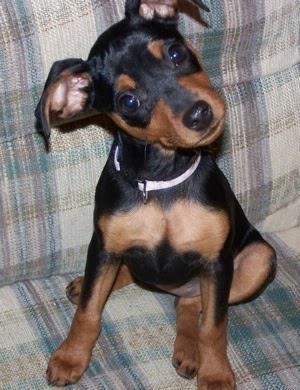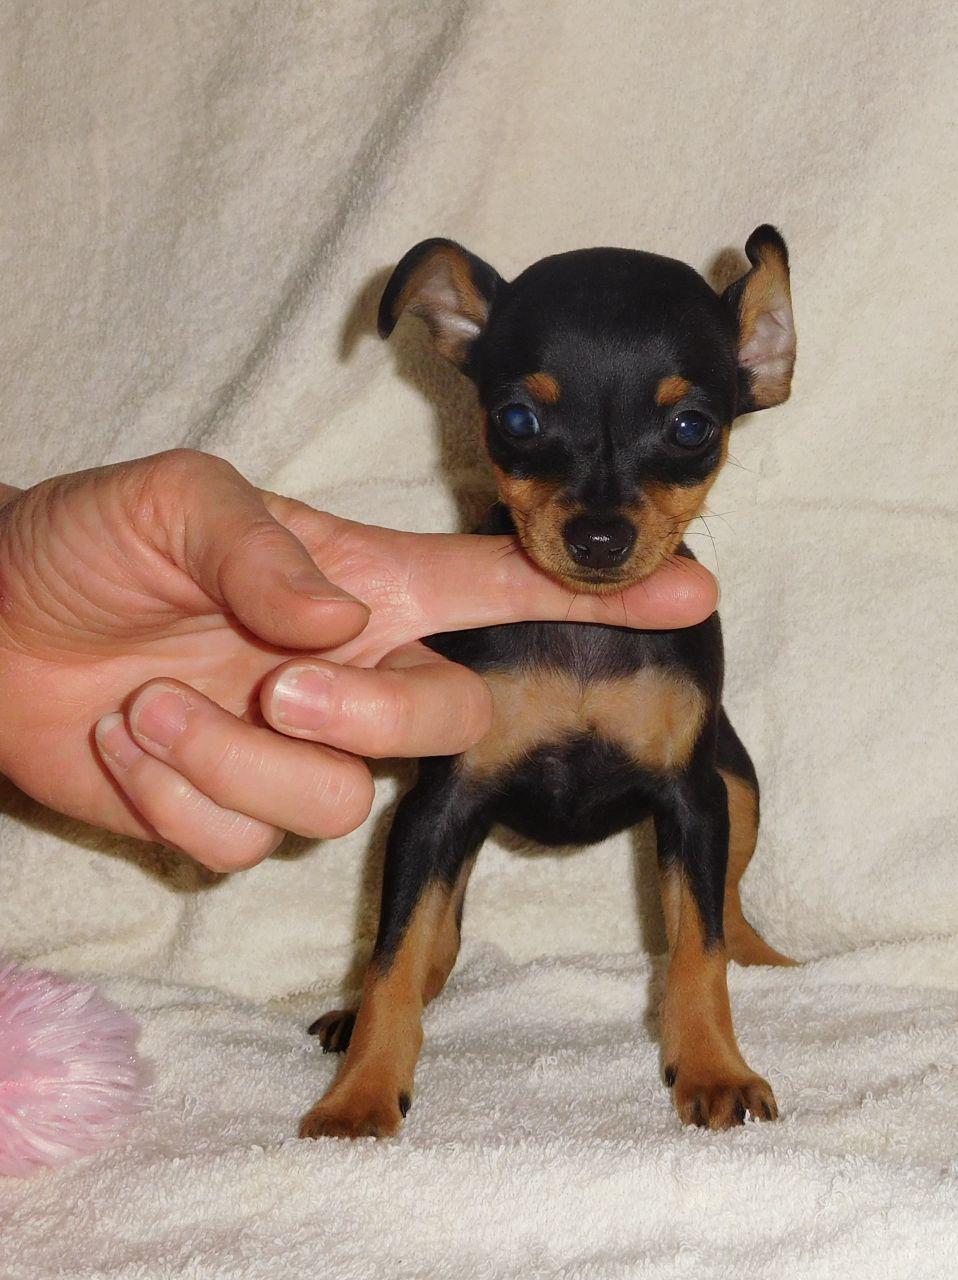The first image is the image on the left, the second image is the image on the right. For the images displayed, is the sentence "One image shows a human hand interacting with a juvenile dog." factually correct? Answer yes or no. Yes. 